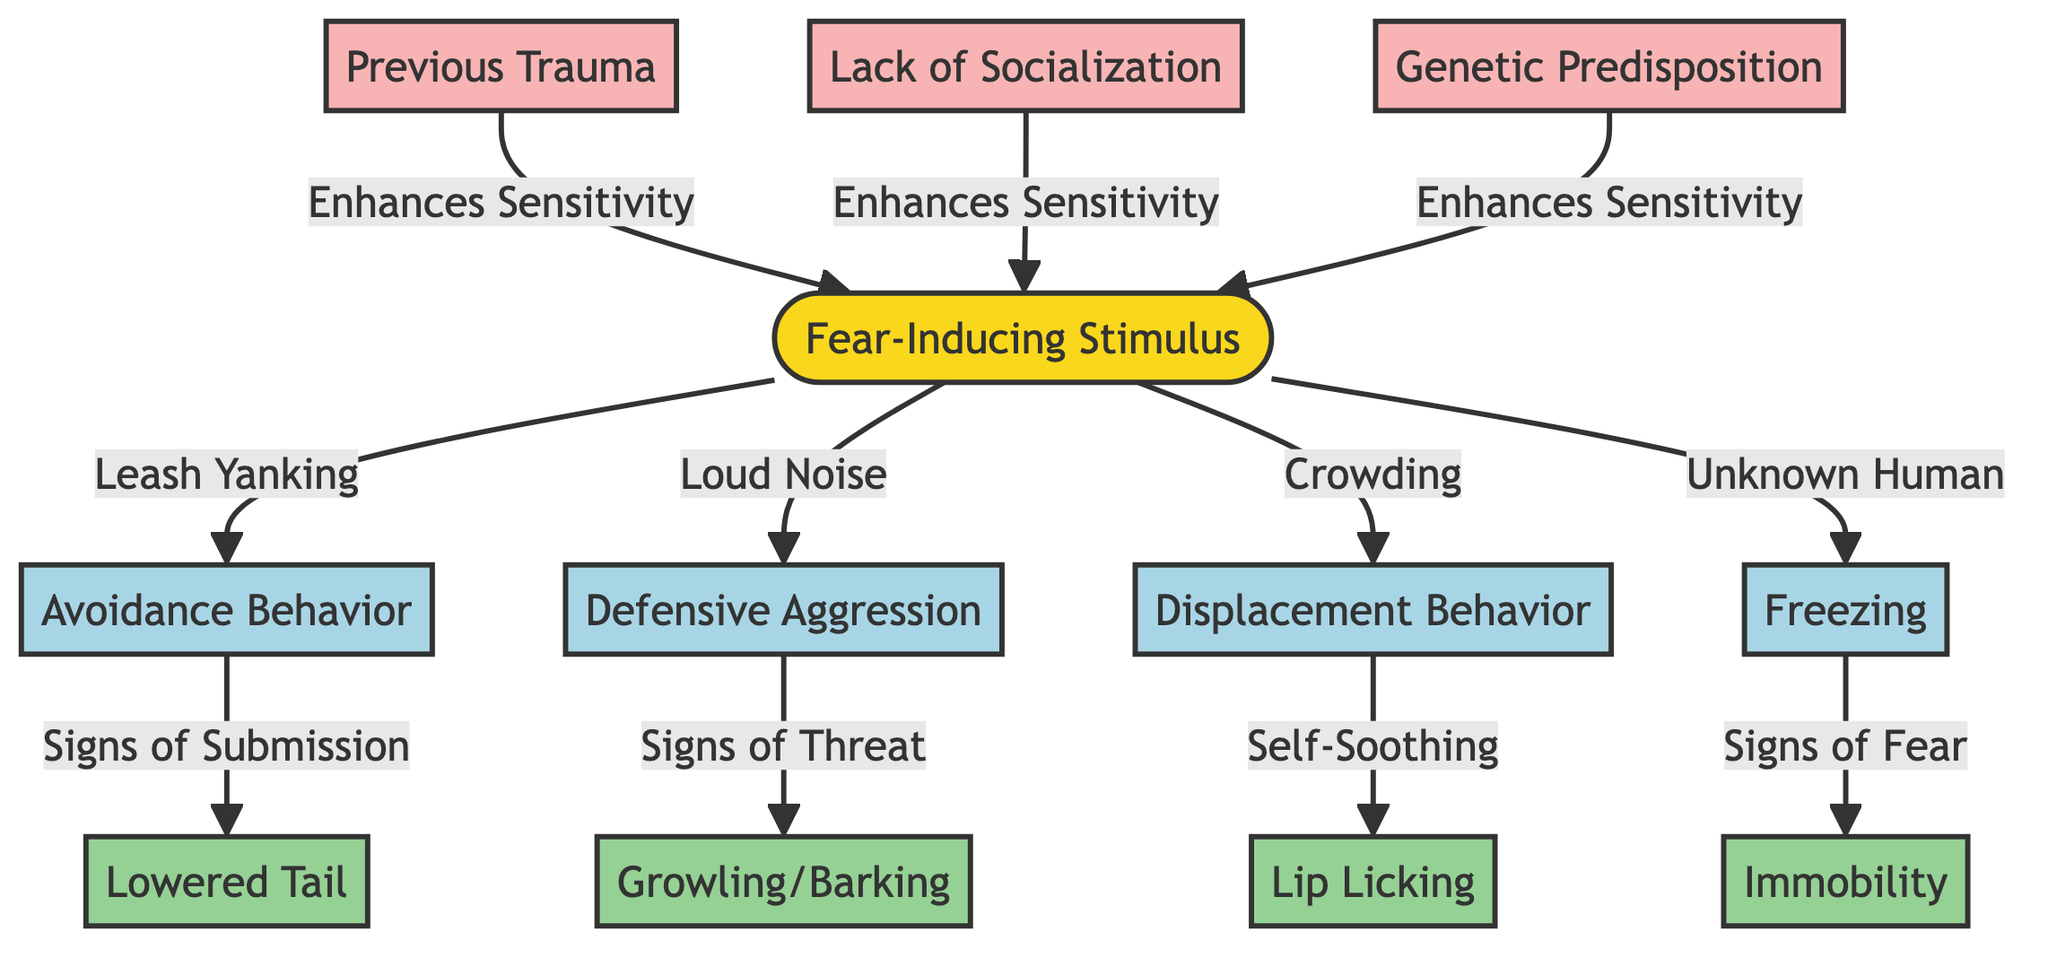What is the primary stimulus described in the diagram? The diagram identifies "Fear-Inducing Stimulus" as the primary stimulus at the top.
Answer: Fear-Inducing Stimulus How many types of behavior are indicated in the diagram? There are four distinct behaviors listed under behaviors in the diagram: Avoidance Behavior, Defensive Aggression, Displacement Behavior, and Freezing.
Answer: 4 What factor enhances sensitivity to the fear-inducing stimulus? The diagram shows three factors that enhance sensitivity, including Previous Trauma, Lack of Socialization, and Genetic Predisposition. Each of these factors connects to the primary stimulus.
Answer: 3 What outcome is associated with Defensive Aggression? The diagram indicates that Defensive Aggression leads to "Signs of Threat," which is the outcome linked to this behavior.
Answer: Signs of Threat Which behavior is triggered by Loud Noise? According to the diagram, "Defensive Aggression" is the behavior that is specifically triggered by a Loud Noise.
Answer: Defensive Aggression What relationship exists between Previous Trauma and the fear-inducing stimulus? The diagram illustrates that Previous Trauma enhances sensitivity to the Fear-Inducing Stimulus, connecting the two with an arrow indicating an influence.
Answer: Enhances Sensitivity Which behavior leads to the outcome of "Signs of Submission"? The diagram states that "Avoidance Behavior" is the behavior leading to the outcome of "Signs of Submission" shown in the lower part of the diagram.
Answer: Avoidance Behavior What is the total number of outcomes listed in the diagram? The diagram lists four outcomes: Lowered Tail, Growling/Barking, Lip Licking, and Immobility. Therefore, the total is four outcomes.
Answer: 4 How does crowding affect canine behavior according to the diagram? The diagram shows that crowding triggers "Displacement Behavior," indicating a direct relationship between the stimulus and the behavior response.
Answer: Displacement Behavior 